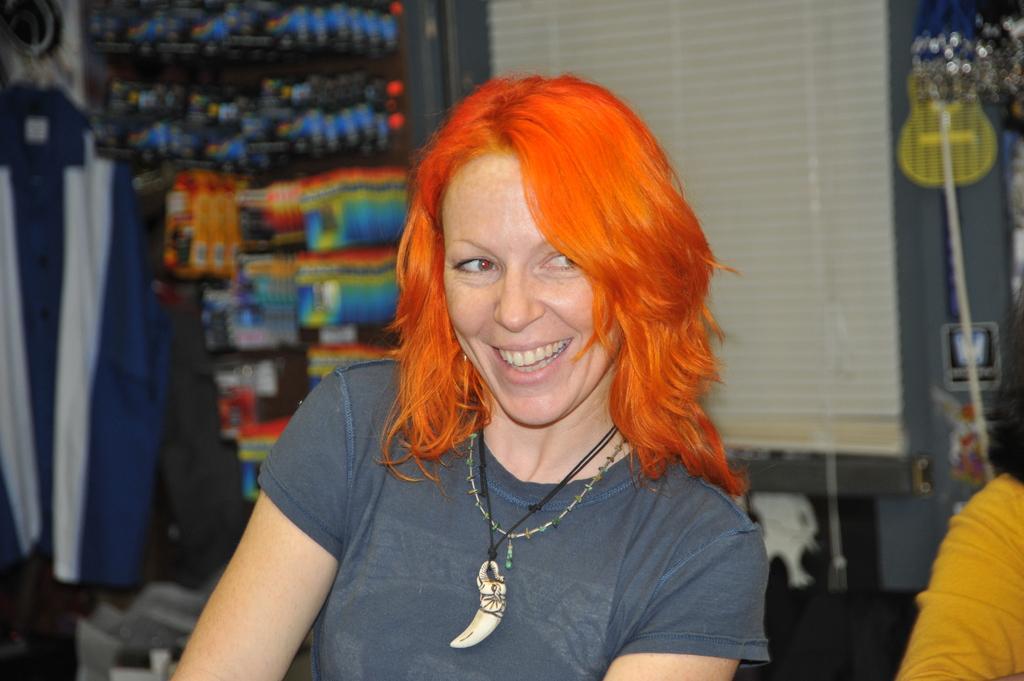Could you give a brief overview of what you see in this image? In the center of the image, we can see a lady smiling and wearing a chain and a pendant. In the background, there are clothes hanging and we can see an other person and some objects in the shelves and some other objects and a curtain. 